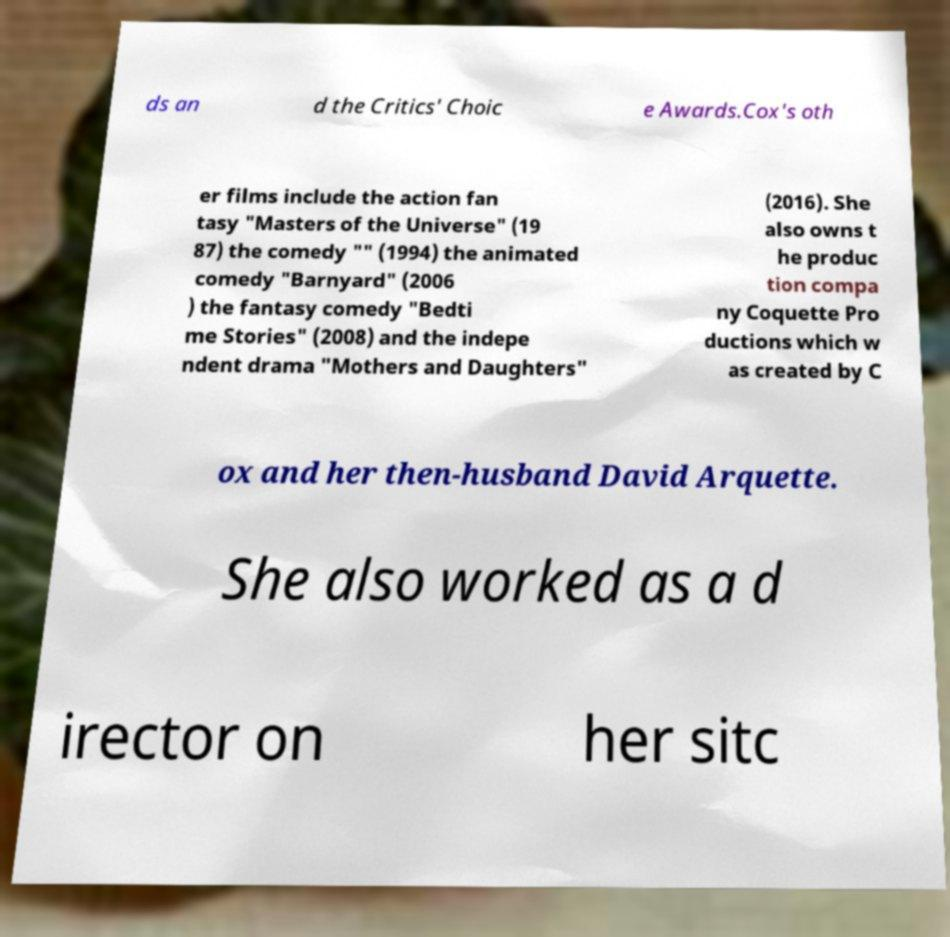Can you read and provide the text displayed in the image?This photo seems to have some interesting text. Can you extract and type it out for me? ds an d the Critics' Choic e Awards.Cox's oth er films include the action fan tasy "Masters of the Universe" (19 87) the comedy "" (1994) the animated comedy "Barnyard" (2006 ) the fantasy comedy "Bedti me Stories" (2008) and the indepe ndent drama "Mothers and Daughters" (2016). She also owns t he produc tion compa ny Coquette Pro ductions which w as created by C ox and her then-husband David Arquette. She also worked as a d irector on her sitc 